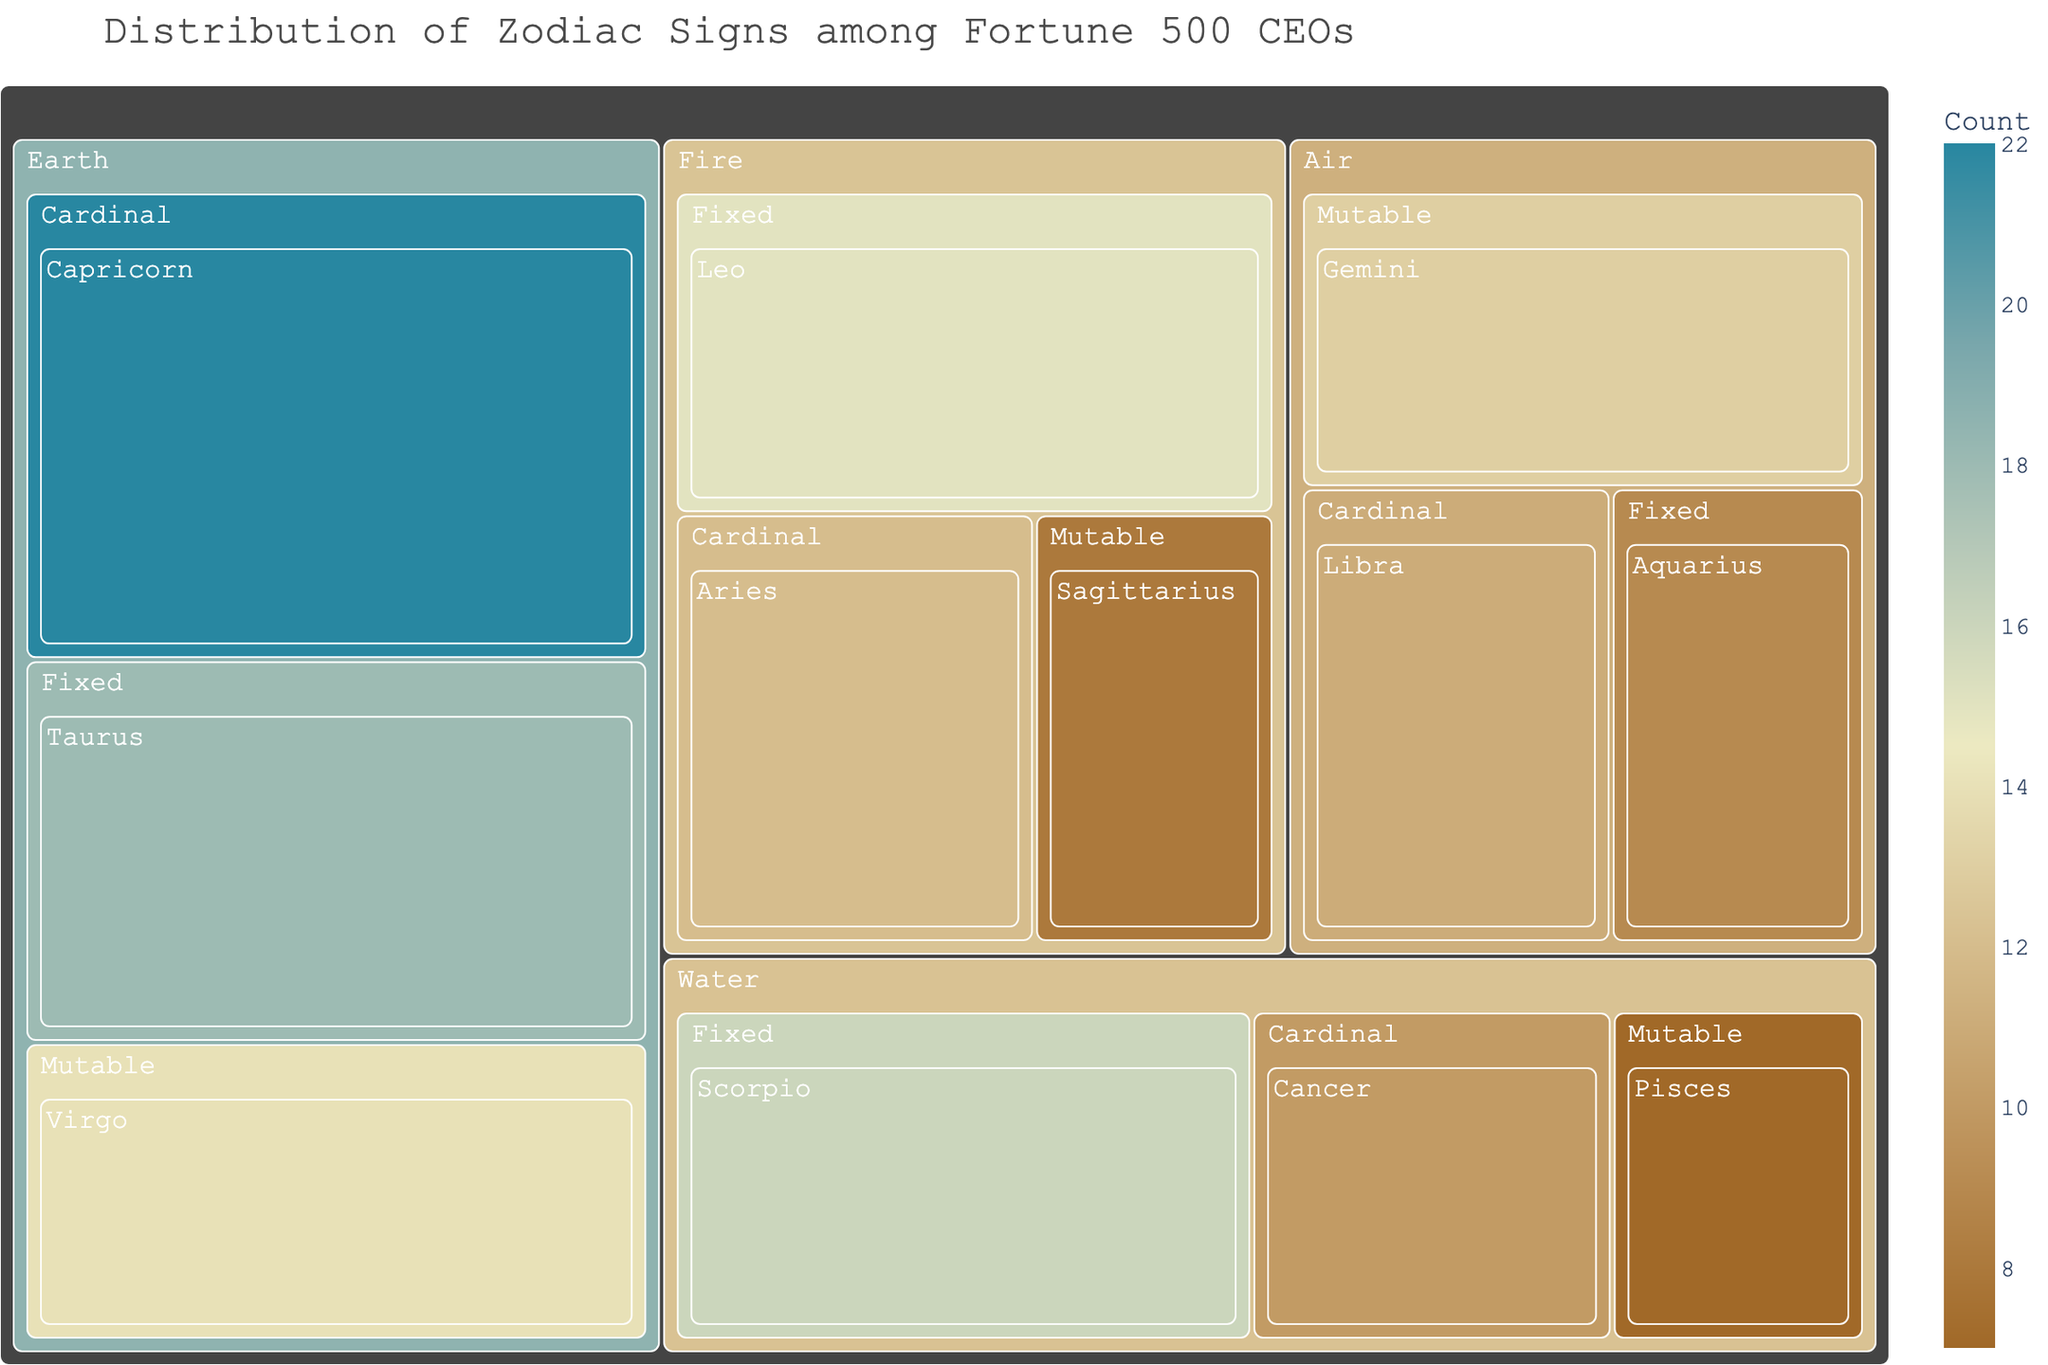What's the title of the treemap? The title is displayed at the top of the treemap and typically summarizes the main topic or insight of the visualization.
Answer: Distribution of Zodiac Signs among Fortune 500 CEOs Which zodiac sign has the highest count among Fortune 500 CEOs? By looking at the cells representing different zodiac signs, the largest cell typically indicates the highest count.
Answer: Capricorn How many more CEOs are Aries compared to Pisces? Identify the counts for Aries and Pisces (12 and 7, respectively). Then, subtract the smaller count from the larger one.
Answer: 5 What is the total number of CEOs having a Fire element in their zodiac signs? Sum up the counts for Aries, Leo, and Sagittarius, which belong to the Fire element: 12 (Aries) + 15 (Leo) + 8 (Sagittarius).
Answer: 35 Which modality has the highest total number of CEOs? Add up the counts for each modality (Cardinal, Fixed, Mutable) across all elements and compare the sums.
Answer: Fixed Compare the number of CEOs with Earth zodiac signs to those with Water zodiac signs. Which group is larger and by how much? Sum the counts for Earth signs (Capricorn, Taurus, Virgo) and Water signs (Cancer, Scorpio, Pisces): Earth = 22 (Capricorn) + 18 (Taurus) + 14 (Virgo) = 54, Water = 10 (Cancer) + 16 (Scorpio) + 7 (Pisces) = 33. Subtract the smaller sum from the larger one.
Answer: Earth by 21 Which cardinal sign is least represented among Fortune 500 CEOs? Look at the counts for all cardinal signs: Aries (12), Capricorn (22), Libra (11), Cancer (10) and identify the smallest number.
Answer: Cancer How do the number of Air sign CEOs compare between Fixed and Mutable modalities? Identify the counts for Air signs under Fixed (Aquarius, 9) and Mutable (Gemini, 13) and compare these numbers.
Answer: Mutable (Gemini) is higher by 4 What is the average number of CEOs per zodiac sign? Sum up all the counts and divide by the total number of zodiac signs: (12 + 15 + 8 + 22 + 18 + 14 + 11 + 9 + 13 + 10 + 16 + 7) / 12.
Answer: 13.25 Which fixed sign has the highest count among Fortune 500 CEOs? Compare the counts of Fixed signs: Leo (15), Taurus (18), Aquarius (9), Scorpio (16) and identify the highest.
Answer: Taurus 